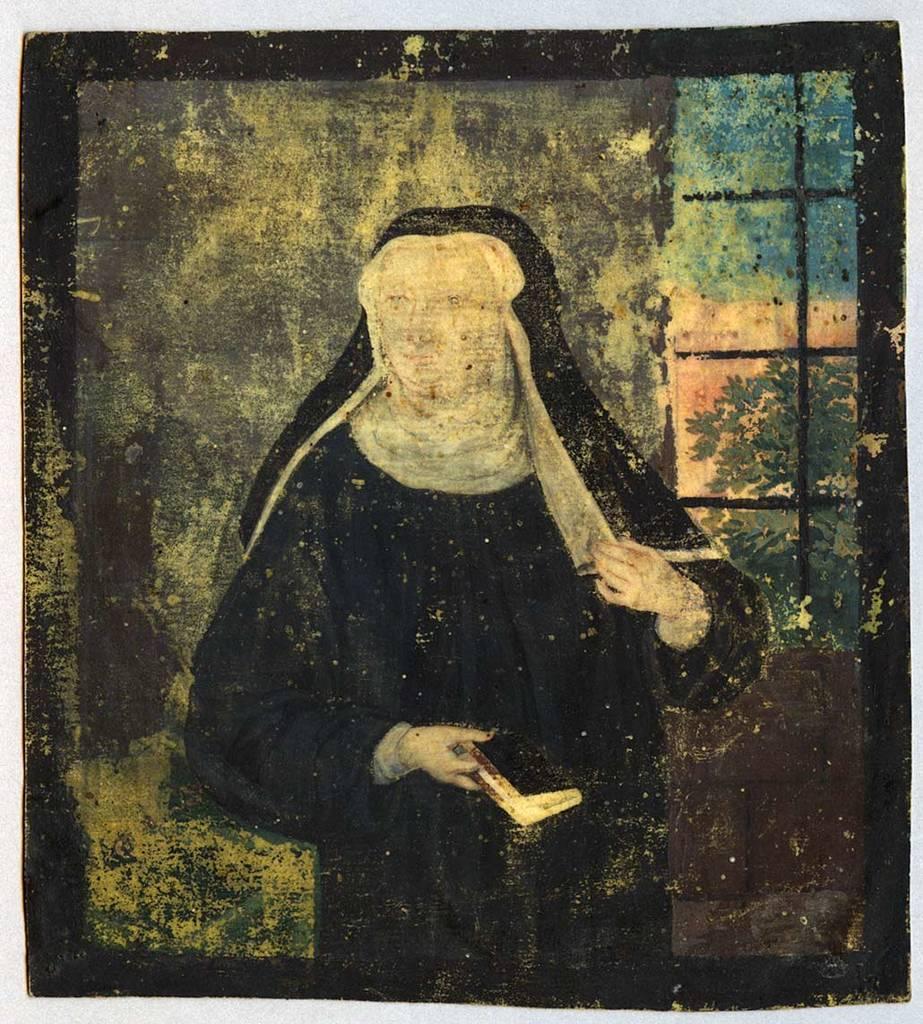Can you describe this image briefly? This is a painting. In this painting we can see there is a woman in a black color dress, watching something. In the background, there is a wall of a building having a window. Through this window, we can see there are trees and a plant. 